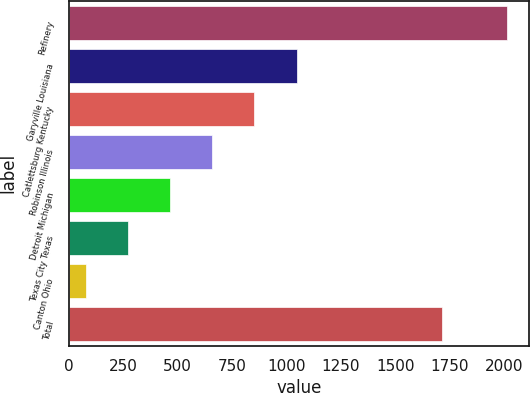Convert chart. <chart><loc_0><loc_0><loc_500><loc_500><bar_chart><fcel>Refinery<fcel>Garyville Louisiana<fcel>Catlettsburg Kentucky<fcel>Robinson Illinois<fcel>Detroit Michigan<fcel>Texas City Texas<fcel>Canton Ohio<fcel>Total<nl><fcel>2013<fcel>1046.5<fcel>853.2<fcel>659.9<fcel>466.6<fcel>273.3<fcel>80<fcel>1714<nl></chart> 